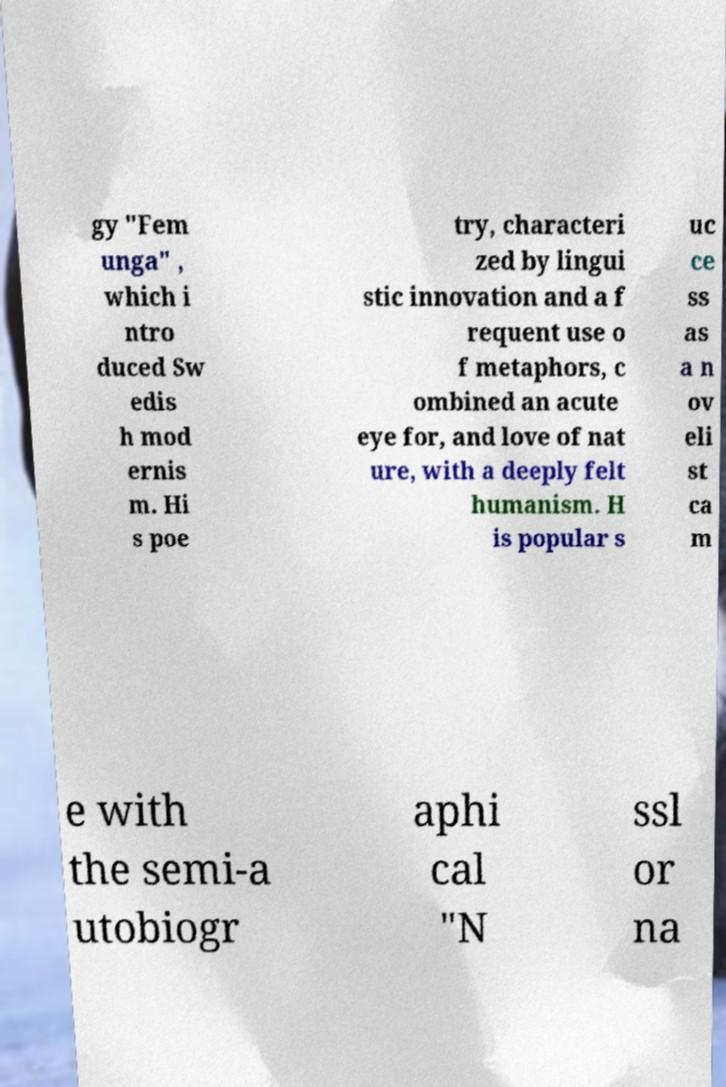Could you assist in decoding the text presented in this image and type it out clearly? gy "Fem unga" , which i ntro duced Sw edis h mod ernis m. Hi s poe try, characteri zed by lingui stic innovation and a f requent use o f metaphors, c ombined an acute eye for, and love of nat ure, with a deeply felt humanism. H is popular s uc ce ss as a n ov eli st ca m e with the semi-a utobiogr aphi cal "N ssl or na 